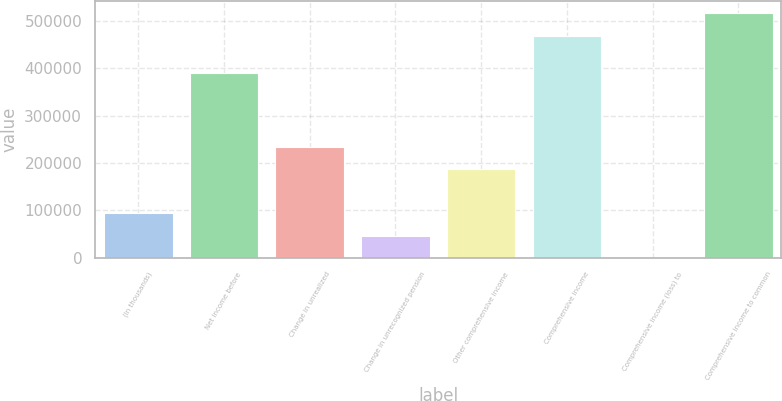<chart> <loc_0><loc_0><loc_500><loc_500><bar_chart><fcel>(In thousands)<fcel>Net income before<fcel>Change in unrealized<fcel>Change in unrecognized pension<fcel>Other comprehensive income<fcel>Comprehensive income<fcel>Comprehensive income (loss) to<fcel>Comprehensive income to common<nl><fcel>93999.8<fcel>391141<fcel>234812<fcel>47062.4<fcel>187875<fcel>469374<fcel>125<fcel>516311<nl></chart> 